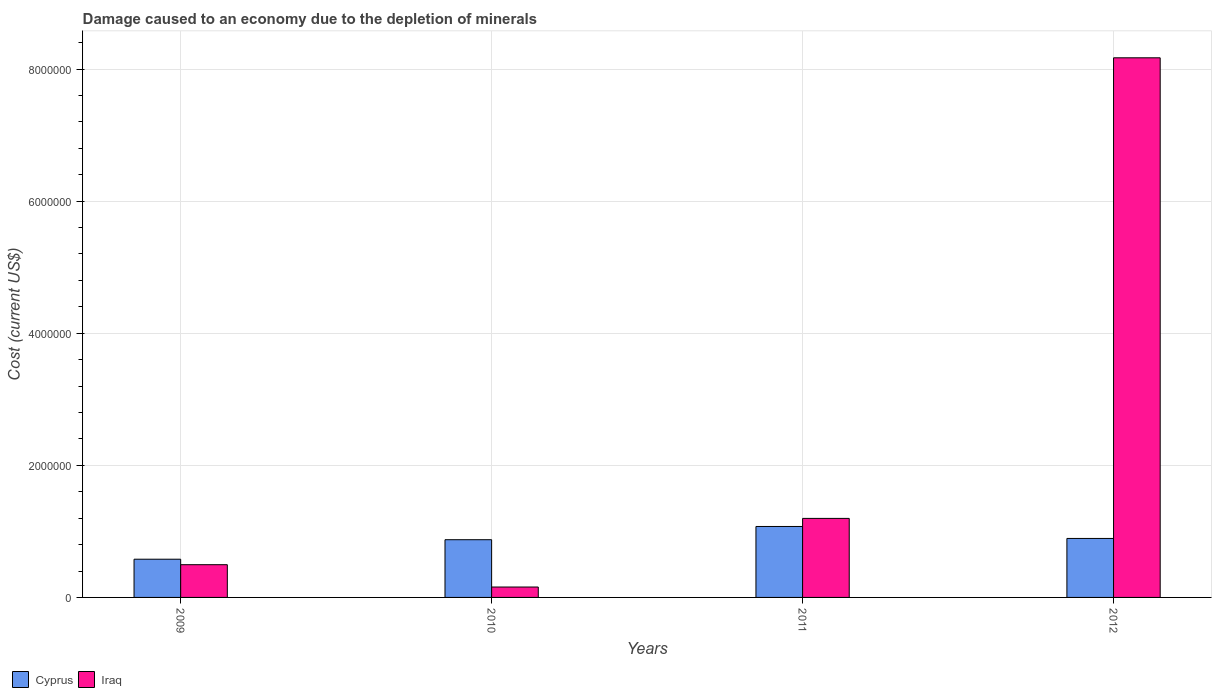Are the number of bars per tick equal to the number of legend labels?
Make the answer very short. Yes. Are the number of bars on each tick of the X-axis equal?
Your response must be concise. Yes. How many bars are there on the 1st tick from the left?
Keep it short and to the point. 2. What is the label of the 4th group of bars from the left?
Your answer should be compact. 2012. In how many cases, is the number of bars for a given year not equal to the number of legend labels?
Keep it short and to the point. 0. What is the cost of damage caused due to the depletion of minerals in Cyprus in 2010?
Offer a terse response. 8.74e+05. Across all years, what is the maximum cost of damage caused due to the depletion of minerals in Cyprus?
Offer a terse response. 1.07e+06. Across all years, what is the minimum cost of damage caused due to the depletion of minerals in Cyprus?
Ensure brevity in your answer.  5.79e+05. In which year was the cost of damage caused due to the depletion of minerals in Iraq maximum?
Give a very brief answer. 2012. In which year was the cost of damage caused due to the depletion of minerals in Cyprus minimum?
Provide a succinct answer. 2009. What is the total cost of damage caused due to the depletion of minerals in Cyprus in the graph?
Your answer should be very brief. 3.42e+06. What is the difference between the cost of damage caused due to the depletion of minerals in Iraq in 2010 and that in 2012?
Give a very brief answer. -8.01e+06. What is the difference between the cost of damage caused due to the depletion of minerals in Iraq in 2011 and the cost of damage caused due to the depletion of minerals in Cyprus in 2010?
Offer a terse response. 3.23e+05. What is the average cost of damage caused due to the depletion of minerals in Iraq per year?
Your response must be concise. 2.50e+06. In the year 2010, what is the difference between the cost of damage caused due to the depletion of minerals in Cyprus and cost of damage caused due to the depletion of minerals in Iraq?
Your answer should be very brief. 7.17e+05. In how many years, is the cost of damage caused due to the depletion of minerals in Iraq greater than 1200000 US$?
Give a very brief answer. 1. What is the ratio of the cost of damage caused due to the depletion of minerals in Cyprus in 2010 to that in 2011?
Keep it short and to the point. 0.81. Is the difference between the cost of damage caused due to the depletion of minerals in Cyprus in 2009 and 2011 greater than the difference between the cost of damage caused due to the depletion of minerals in Iraq in 2009 and 2011?
Provide a succinct answer. Yes. What is the difference between the highest and the second highest cost of damage caused due to the depletion of minerals in Iraq?
Your response must be concise. 6.97e+06. What is the difference between the highest and the lowest cost of damage caused due to the depletion of minerals in Iraq?
Your answer should be compact. 8.01e+06. In how many years, is the cost of damage caused due to the depletion of minerals in Iraq greater than the average cost of damage caused due to the depletion of minerals in Iraq taken over all years?
Provide a short and direct response. 1. Is the sum of the cost of damage caused due to the depletion of minerals in Cyprus in 2010 and 2011 greater than the maximum cost of damage caused due to the depletion of minerals in Iraq across all years?
Give a very brief answer. No. What does the 1st bar from the left in 2012 represents?
Keep it short and to the point. Cyprus. What does the 2nd bar from the right in 2010 represents?
Offer a very short reply. Cyprus. How many bars are there?
Ensure brevity in your answer.  8. Are all the bars in the graph horizontal?
Give a very brief answer. No. Are the values on the major ticks of Y-axis written in scientific E-notation?
Your answer should be compact. No. Does the graph contain any zero values?
Provide a short and direct response. No. Where does the legend appear in the graph?
Offer a terse response. Bottom left. What is the title of the graph?
Ensure brevity in your answer.  Damage caused to an economy due to the depletion of minerals. What is the label or title of the Y-axis?
Make the answer very short. Cost (current US$). What is the Cost (current US$) of Cyprus in 2009?
Your response must be concise. 5.79e+05. What is the Cost (current US$) in Iraq in 2009?
Provide a succinct answer. 4.96e+05. What is the Cost (current US$) in Cyprus in 2010?
Offer a very short reply. 8.74e+05. What is the Cost (current US$) of Iraq in 2010?
Your answer should be very brief. 1.57e+05. What is the Cost (current US$) of Cyprus in 2011?
Your response must be concise. 1.07e+06. What is the Cost (current US$) of Iraq in 2011?
Offer a very short reply. 1.20e+06. What is the Cost (current US$) in Cyprus in 2012?
Your answer should be very brief. 8.93e+05. What is the Cost (current US$) in Iraq in 2012?
Offer a very short reply. 8.17e+06. Across all years, what is the maximum Cost (current US$) in Cyprus?
Keep it short and to the point. 1.07e+06. Across all years, what is the maximum Cost (current US$) in Iraq?
Your answer should be very brief. 8.17e+06. Across all years, what is the minimum Cost (current US$) of Cyprus?
Provide a short and direct response. 5.79e+05. Across all years, what is the minimum Cost (current US$) in Iraq?
Offer a very short reply. 1.57e+05. What is the total Cost (current US$) of Cyprus in the graph?
Your answer should be very brief. 3.42e+06. What is the total Cost (current US$) of Iraq in the graph?
Provide a succinct answer. 1.00e+07. What is the difference between the Cost (current US$) in Cyprus in 2009 and that in 2010?
Provide a succinct answer. -2.95e+05. What is the difference between the Cost (current US$) of Iraq in 2009 and that in 2010?
Provide a succinct answer. 3.38e+05. What is the difference between the Cost (current US$) in Cyprus in 2009 and that in 2011?
Give a very brief answer. -4.96e+05. What is the difference between the Cost (current US$) of Iraq in 2009 and that in 2011?
Your response must be concise. -7.01e+05. What is the difference between the Cost (current US$) of Cyprus in 2009 and that in 2012?
Keep it short and to the point. -3.14e+05. What is the difference between the Cost (current US$) in Iraq in 2009 and that in 2012?
Keep it short and to the point. -7.67e+06. What is the difference between the Cost (current US$) in Cyprus in 2010 and that in 2011?
Your answer should be very brief. -2.00e+05. What is the difference between the Cost (current US$) in Iraq in 2010 and that in 2011?
Your response must be concise. -1.04e+06. What is the difference between the Cost (current US$) in Cyprus in 2010 and that in 2012?
Give a very brief answer. -1.92e+04. What is the difference between the Cost (current US$) of Iraq in 2010 and that in 2012?
Give a very brief answer. -8.01e+06. What is the difference between the Cost (current US$) of Cyprus in 2011 and that in 2012?
Provide a short and direct response. 1.81e+05. What is the difference between the Cost (current US$) of Iraq in 2011 and that in 2012?
Give a very brief answer. -6.97e+06. What is the difference between the Cost (current US$) in Cyprus in 2009 and the Cost (current US$) in Iraq in 2010?
Provide a short and direct response. 4.21e+05. What is the difference between the Cost (current US$) in Cyprus in 2009 and the Cost (current US$) in Iraq in 2011?
Your answer should be compact. -6.18e+05. What is the difference between the Cost (current US$) of Cyprus in 2009 and the Cost (current US$) of Iraq in 2012?
Offer a terse response. -7.59e+06. What is the difference between the Cost (current US$) of Cyprus in 2010 and the Cost (current US$) of Iraq in 2011?
Offer a terse response. -3.23e+05. What is the difference between the Cost (current US$) of Cyprus in 2010 and the Cost (current US$) of Iraq in 2012?
Provide a succinct answer. -7.30e+06. What is the difference between the Cost (current US$) of Cyprus in 2011 and the Cost (current US$) of Iraq in 2012?
Your answer should be compact. -7.10e+06. What is the average Cost (current US$) in Cyprus per year?
Offer a very short reply. 8.55e+05. What is the average Cost (current US$) in Iraq per year?
Ensure brevity in your answer.  2.50e+06. In the year 2009, what is the difference between the Cost (current US$) in Cyprus and Cost (current US$) in Iraq?
Make the answer very short. 8.31e+04. In the year 2010, what is the difference between the Cost (current US$) of Cyprus and Cost (current US$) of Iraq?
Make the answer very short. 7.17e+05. In the year 2011, what is the difference between the Cost (current US$) of Cyprus and Cost (current US$) of Iraq?
Your response must be concise. -1.22e+05. In the year 2012, what is the difference between the Cost (current US$) of Cyprus and Cost (current US$) of Iraq?
Provide a succinct answer. -7.28e+06. What is the ratio of the Cost (current US$) in Cyprus in 2009 to that in 2010?
Provide a succinct answer. 0.66. What is the ratio of the Cost (current US$) of Iraq in 2009 to that in 2010?
Your answer should be very brief. 3.15. What is the ratio of the Cost (current US$) of Cyprus in 2009 to that in 2011?
Make the answer very short. 0.54. What is the ratio of the Cost (current US$) of Iraq in 2009 to that in 2011?
Keep it short and to the point. 0.41. What is the ratio of the Cost (current US$) of Cyprus in 2009 to that in 2012?
Offer a very short reply. 0.65. What is the ratio of the Cost (current US$) of Iraq in 2009 to that in 2012?
Give a very brief answer. 0.06. What is the ratio of the Cost (current US$) of Cyprus in 2010 to that in 2011?
Offer a terse response. 0.81. What is the ratio of the Cost (current US$) of Iraq in 2010 to that in 2011?
Give a very brief answer. 0.13. What is the ratio of the Cost (current US$) of Cyprus in 2010 to that in 2012?
Provide a short and direct response. 0.98. What is the ratio of the Cost (current US$) in Iraq in 2010 to that in 2012?
Provide a short and direct response. 0.02. What is the ratio of the Cost (current US$) in Cyprus in 2011 to that in 2012?
Ensure brevity in your answer.  1.2. What is the ratio of the Cost (current US$) of Iraq in 2011 to that in 2012?
Your response must be concise. 0.15. What is the difference between the highest and the second highest Cost (current US$) of Cyprus?
Make the answer very short. 1.81e+05. What is the difference between the highest and the second highest Cost (current US$) of Iraq?
Your answer should be compact. 6.97e+06. What is the difference between the highest and the lowest Cost (current US$) of Cyprus?
Ensure brevity in your answer.  4.96e+05. What is the difference between the highest and the lowest Cost (current US$) in Iraq?
Give a very brief answer. 8.01e+06. 